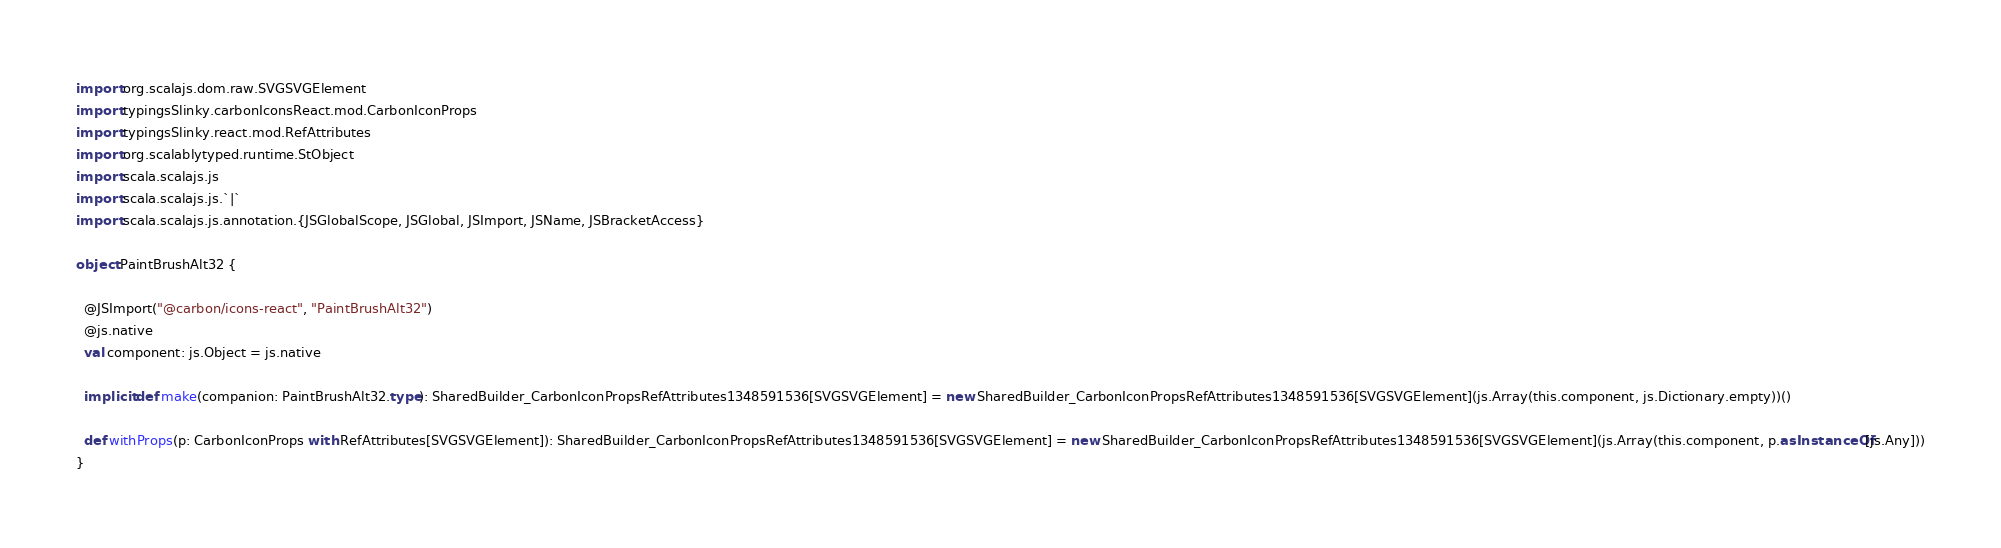<code> <loc_0><loc_0><loc_500><loc_500><_Scala_>import org.scalajs.dom.raw.SVGSVGElement
import typingsSlinky.carbonIconsReact.mod.CarbonIconProps
import typingsSlinky.react.mod.RefAttributes
import org.scalablytyped.runtime.StObject
import scala.scalajs.js
import scala.scalajs.js.`|`
import scala.scalajs.js.annotation.{JSGlobalScope, JSGlobal, JSImport, JSName, JSBracketAccess}

object PaintBrushAlt32 {
  
  @JSImport("@carbon/icons-react", "PaintBrushAlt32")
  @js.native
  val component: js.Object = js.native
  
  implicit def make(companion: PaintBrushAlt32.type): SharedBuilder_CarbonIconPropsRefAttributes1348591536[SVGSVGElement] = new SharedBuilder_CarbonIconPropsRefAttributes1348591536[SVGSVGElement](js.Array(this.component, js.Dictionary.empty))()
  
  def withProps(p: CarbonIconProps with RefAttributes[SVGSVGElement]): SharedBuilder_CarbonIconPropsRefAttributes1348591536[SVGSVGElement] = new SharedBuilder_CarbonIconPropsRefAttributes1348591536[SVGSVGElement](js.Array(this.component, p.asInstanceOf[js.Any]))
}
</code> 